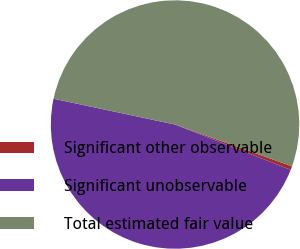<chart> <loc_0><loc_0><loc_500><loc_500><pie_chart><fcel>Significant other observable<fcel>Significant unobservable<fcel>Total estimated fair value<nl><fcel>0.48%<fcel>47.39%<fcel>52.13%<nl></chart> 